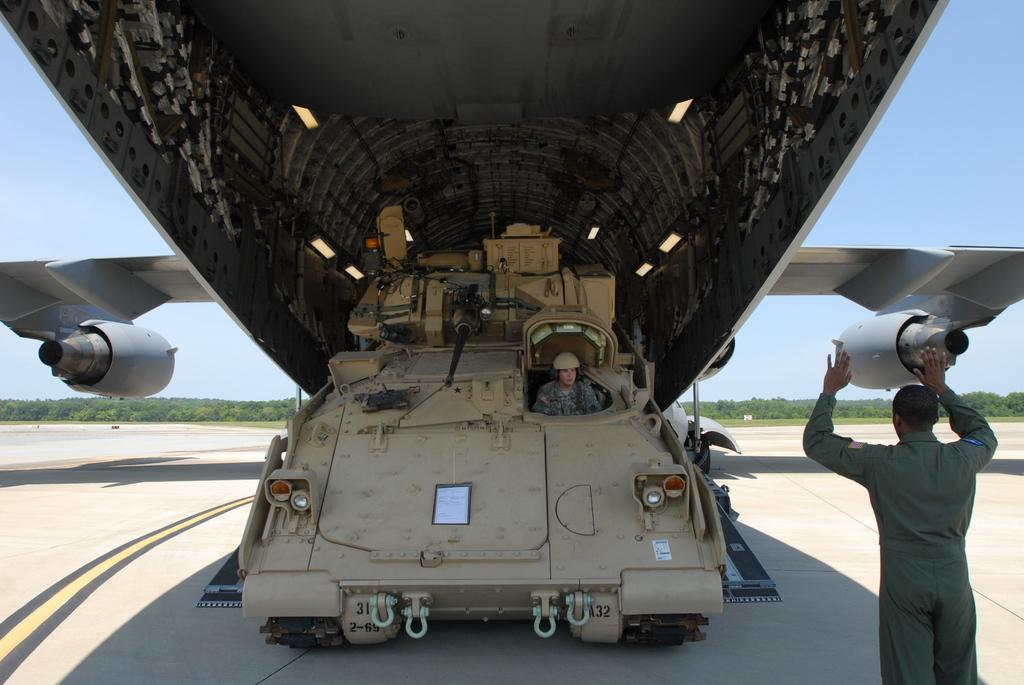What is the main subject of the image? The main subject of the image is an aeroplane. What else can be seen in the image besides the aeroplane? There is a vehicle in the image, and a person is sitting in the vehicle. Can you describe the man on the right side of the image? There is a man on the right side of the image, but no specific details about his appearance or actions are provided. What is visible in the background of the image? There are trees and the sky visible in the background of the image. What is the purpose of the sack in the image? There is no sack present in the image, so it is not possible to determine its purpose. 